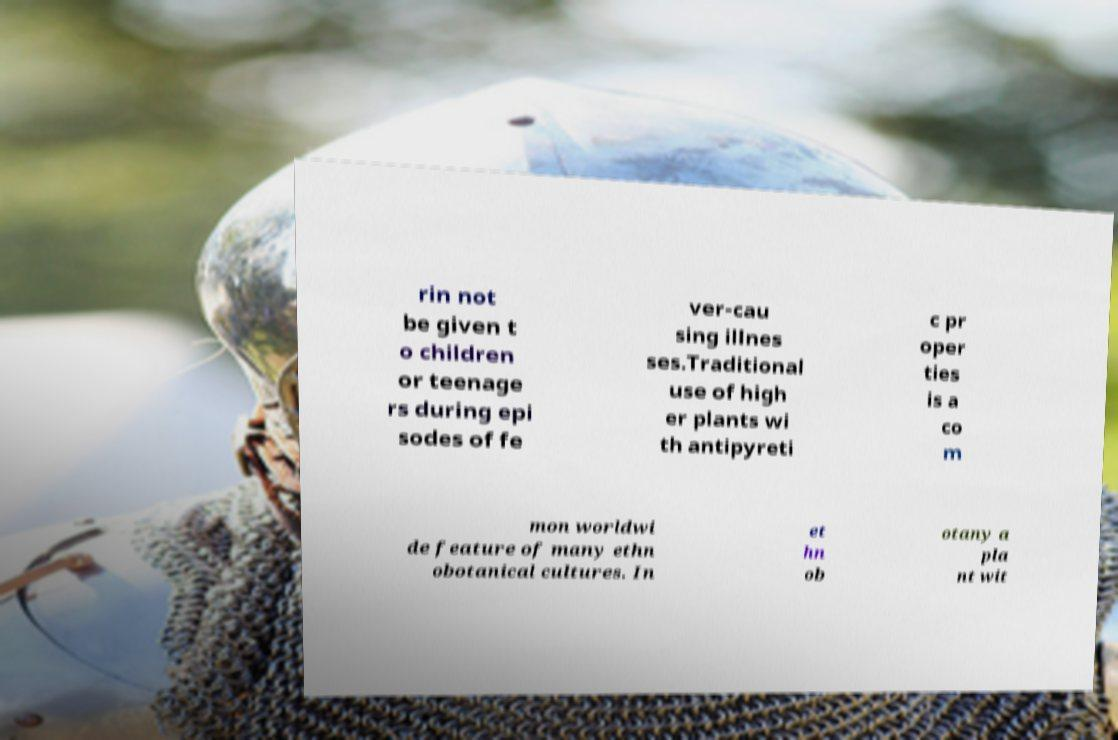Can you accurately transcribe the text from the provided image for me? rin not be given t o children or teenage rs during epi sodes of fe ver-cau sing illnes ses.Traditional use of high er plants wi th antipyreti c pr oper ties is a co m mon worldwi de feature of many ethn obotanical cultures. In et hn ob otany a pla nt wit 